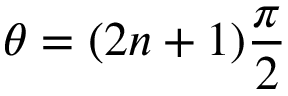Convert formula to latex. <formula><loc_0><loc_0><loc_500><loc_500>\theta = ( 2 n + 1 ) \frac { \pi } { 2 }</formula> 